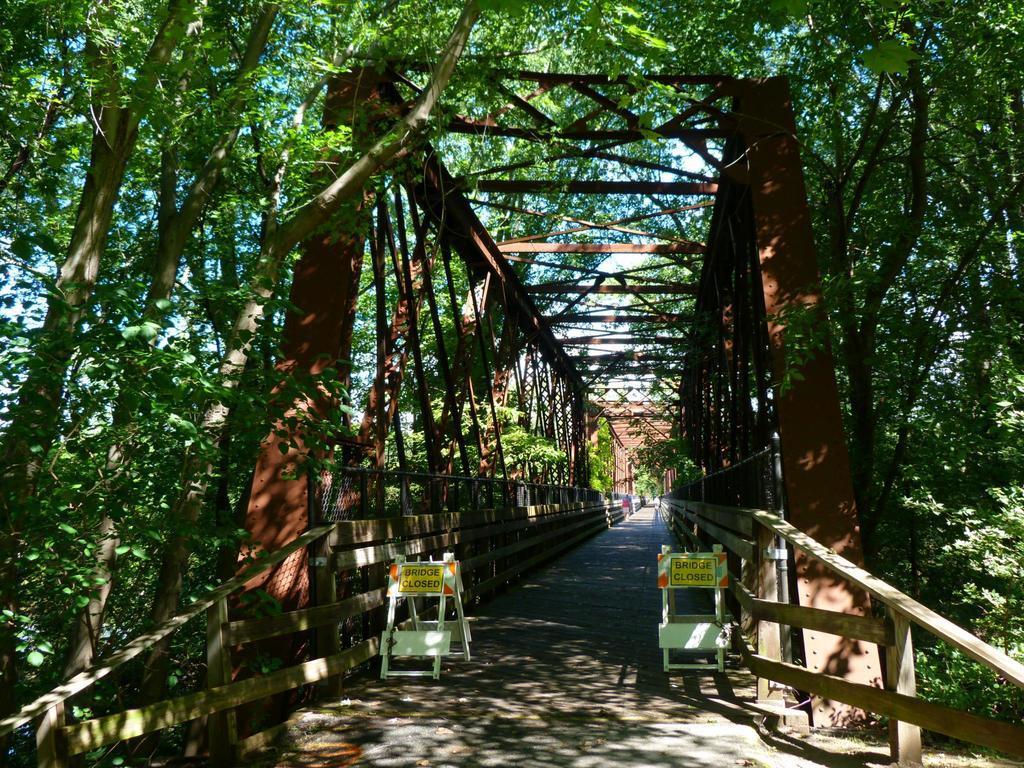Can you describe this image briefly? In the picture we can see a bridge and a path, and beside the entrance of the bridge we can see two boards and written on it as bridge closed and on the either sides of the bridge we can see trees. 